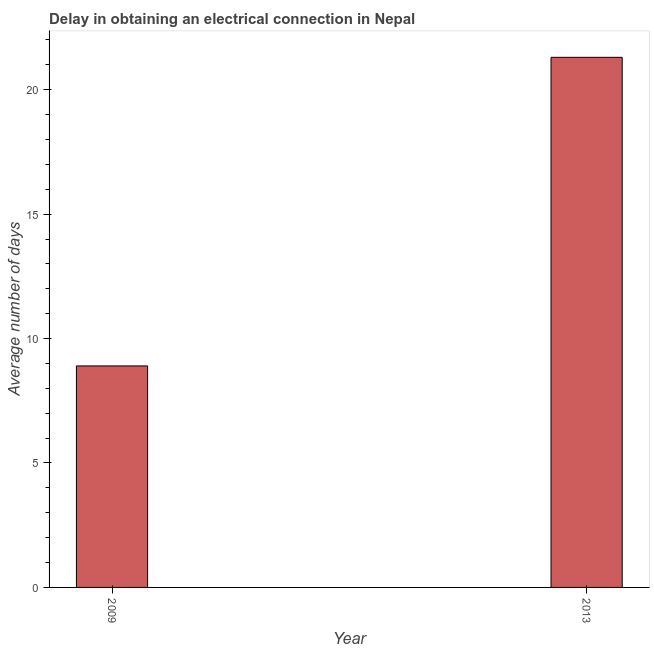Does the graph contain grids?
Ensure brevity in your answer.  No. What is the title of the graph?
Your answer should be very brief. Delay in obtaining an electrical connection in Nepal. What is the label or title of the X-axis?
Provide a short and direct response. Year. What is the label or title of the Y-axis?
Offer a very short reply. Average number of days. What is the dalay in electrical connection in 2009?
Offer a very short reply. 8.9. Across all years, what is the maximum dalay in electrical connection?
Keep it short and to the point. 21.3. In which year was the dalay in electrical connection maximum?
Give a very brief answer. 2013. What is the sum of the dalay in electrical connection?
Ensure brevity in your answer.  30.2. What is the difference between the dalay in electrical connection in 2009 and 2013?
Ensure brevity in your answer.  -12.4. What is the median dalay in electrical connection?
Give a very brief answer. 15.1. In how many years, is the dalay in electrical connection greater than 14 days?
Make the answer very short. 1. What is the ratio of the dalay in electrical connection in 2009 to that in 2013?
Your answer should be compact. 0.42. Is the dalay in electrical connection in 2009 less than that in 2013?
Offer a terse response. Yes. In how many years, is the dalay in electrical connection greater than the average dalay in electrical connection taken over all years?
Provide a succinct answer. 1. How many bars are there?
Give a very brief answer. 2. How many years are there in the graph?
Provide a succinct answer. 2. What is the difference between two consecutive major ticks on the Y-axis?
Offer a very short reply. 5. What is the Average number of days of 2013?
Your answer should be very brief. 21.3. What is the difference between the Average number of days in 2009 and 2013?
Provide a short and direct response. -12.4. What is the ratio of the Average number of days in 2009 to that in 2013?
Your answer should be very brief. 0.42. 